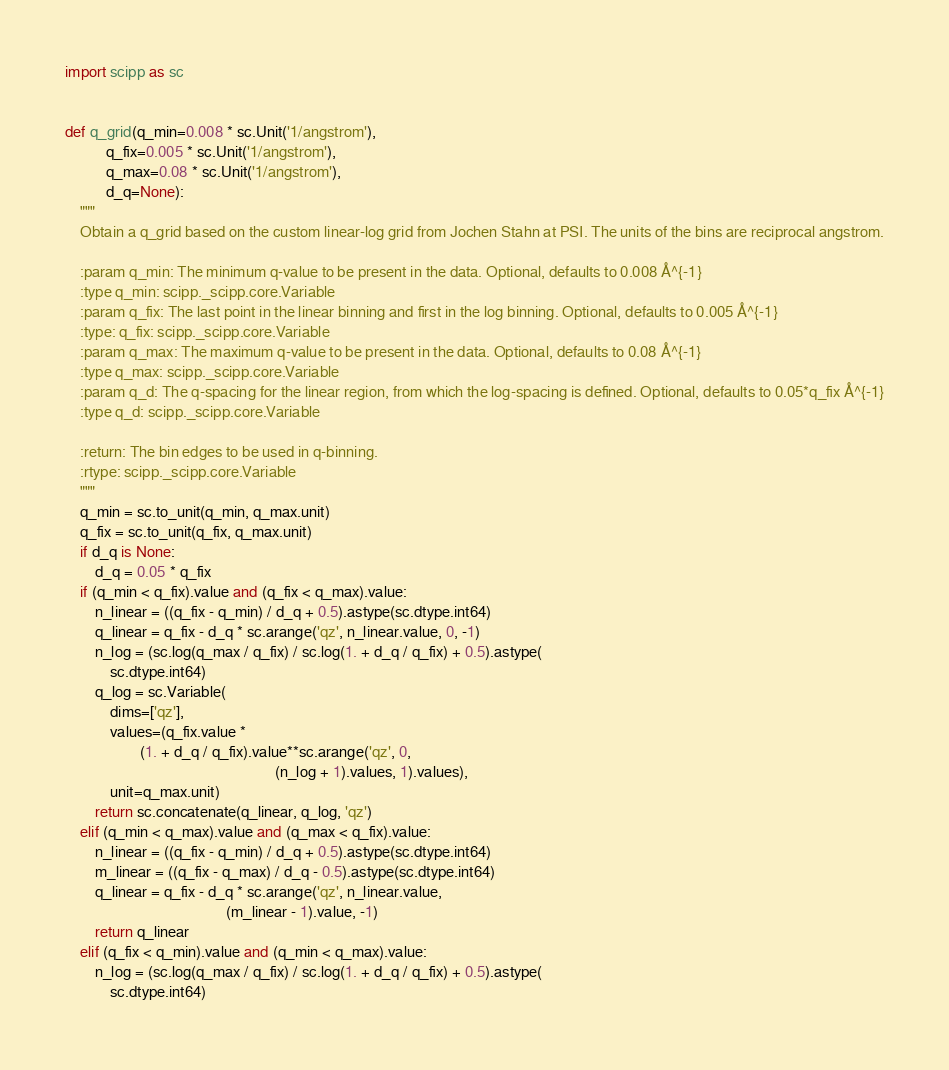<code> <loc_0><loc_0><loc_500><loc_500><_Python_>import scipp as sc


def q_grid(q_min=0.008 * sc.Unit('1/angstrom'),
           q_fix=0.005 * sc.Unit('1/angstrom'),
           q_max=0.08 * sc.Unit('1/angstrom'),
           d_q=None):
    """
    Obtain a q_grid based on the custom linear-log grid from Jochen Stahn at PSI. The units of the bins are reciprocal angstrom.

    :param q_min: The minimum q-value to be present in the data. Optional, defaults to 0.008 Å^{-1}
    :type q_min: scipp._scipp.core.Variable
    :param q_fix: The last point in the linear binning and first in the log binning. Optional, defaults to 0.005 Å^{-1}
    :type: q_fix: scipp._scipp.core.Variable
    :param q_max: The maximum q-value to be present in the data. Optional, defaults to 0.08 Å^{-1}
    :type q_max: scipp._scipp.core.Variable
    :param q_d: The q-spacing for the linear region, from which the log-spacing is defined. Optional, defaults to 0.05*q_fix Å^{-1}
    :type q_d: scipp._scipp.core.Variable

    :return: The bin edges to be used in q-binning.
    :rtype: scipp._scipp.core.Variable
    """
    q_min = sc.to_unit(q_min, q_max.unit)
    q_fix = sc.to_unit(q_fix, q_max.unit)
    if d_q is None:
        d_q = 0.05 * q_fix
    if (q_min < q_fix).value and (q_fix < q_max).value:
        n_linear = ((q_fix - q_min) / d_q + 0.5).astype(sc.dtype.int64)
        q_linear = q_fix - d_q * sc.arange('qz', n_linear.value, 0, -1)
        n_log = (sc.log(q_max / q_fix) / sc.log(1. + d_q / q_fix) + 0.5).astype(
            sc.dtype.int64)
        q_log = sc.Variable(
            dims=['qz'],
            values=(q_fix.value *
                    (1. + d_q / q_fix).value**sc.arange('qz', 0,
                                                        (n_log + 1).values, 1).values),
            unit=q_max.unit)
        return sc.concatenate(q_linear, q_log, 'qz')
    elif (q_min < q_max).value and (q_max < q_fix).value:
        n_linear = ((q_fix - q_min) / d_q + 0.5).astype(sc.dtype.int64)
        m_linear = ((q_fix - q_max) / d_q - 0.5).astype(sc.dtype.int64)
        q_linear = q_fix - d_q * sc.arange('qz', n_linear.value,
                                           (m_linear - 1).value, -1)
        return q_linear
    elif (q_fix < q_min).value and (q_min < q_max).value:
        n_log = (sc.log(q_max / q_fix) / sc.log(1. + d_q / q_fix) + 0.5).astype(
            sc.dtype.int64)</code> 